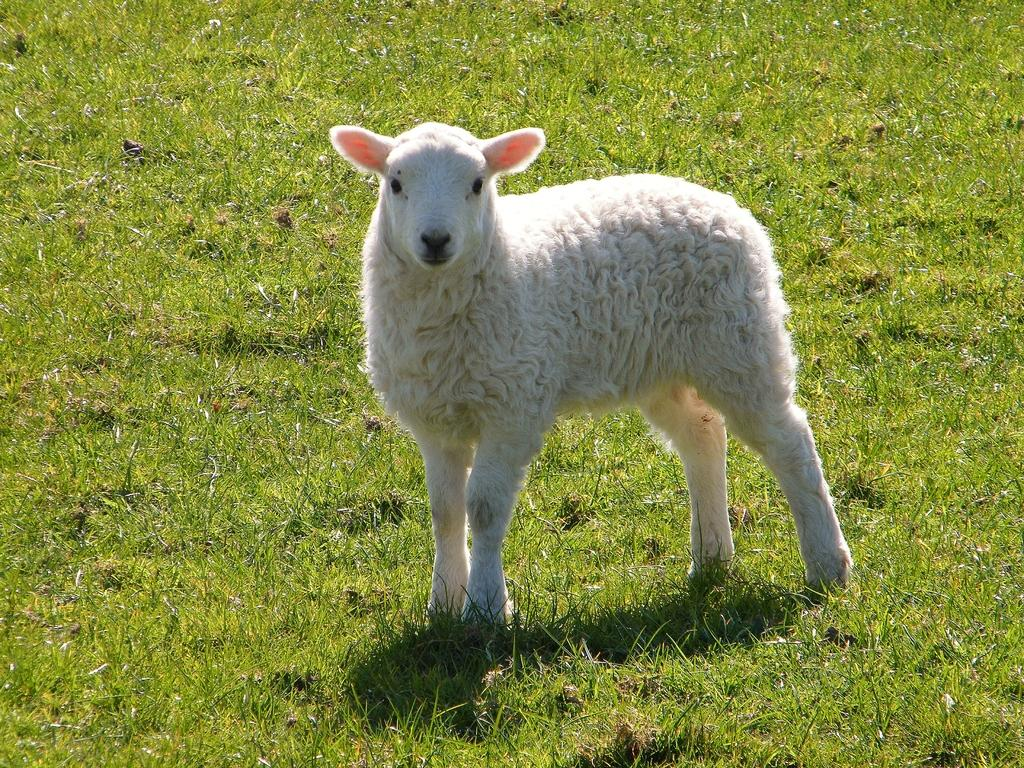What type of terrain is shown in the image? The image depicts a grassy land. Are there any animals visible in the image? Yes, there is one sheep present on the grassy land. What type of locket is the sheep wearing around its neck in the image? There is no locket present around the sheep's neck in the image. How many hands can be seen holding the sheep in the image? There are no hands visible in the image; the sheep is standing alone on the grassy land. 